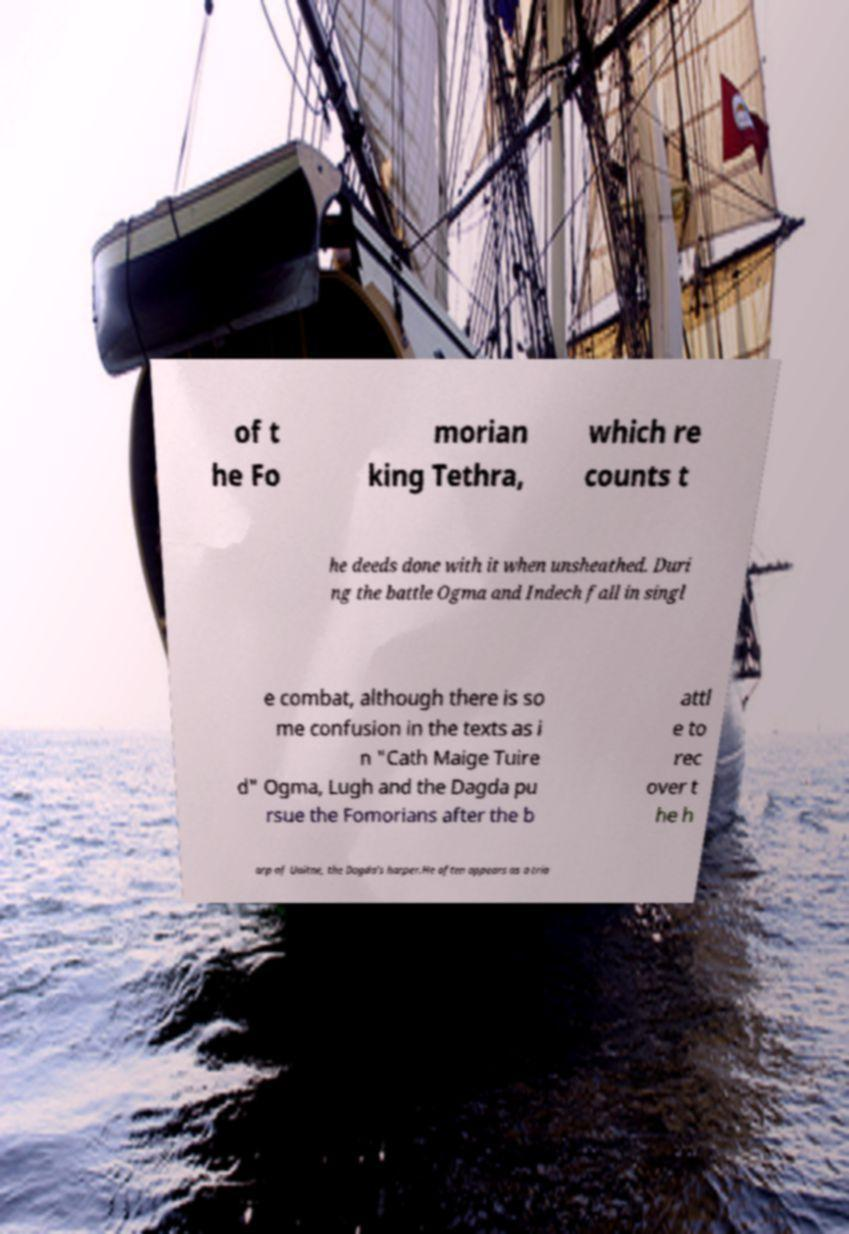Can you accurately transcribe the text from the provided image for me? of t he Fo morian king Tethra, which re counts t he deeds done with it when unsheathed. Duri ng the battle Ogma and Indech fall in singl e combat, although there is so me confusion in the texts as i n "Cath Maige Tuire d" Ogma, Lugh and the Dagda pu rsue the Fomorians after the b attl e to rec over t he h arp of Uaitne, the Dagda's harper.He often appears as a tria 